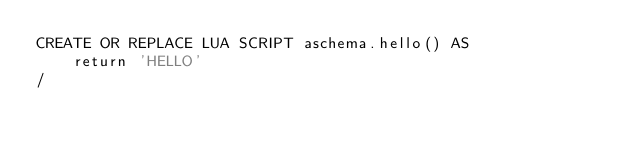Convert code to text. <code><loc_0><loc_0><loc_500><loc_500><_SQL_>CREATE OR REPLACE LUA SCRIPT aschema.hello() AS
    return 'HELLO'
/
</code> 